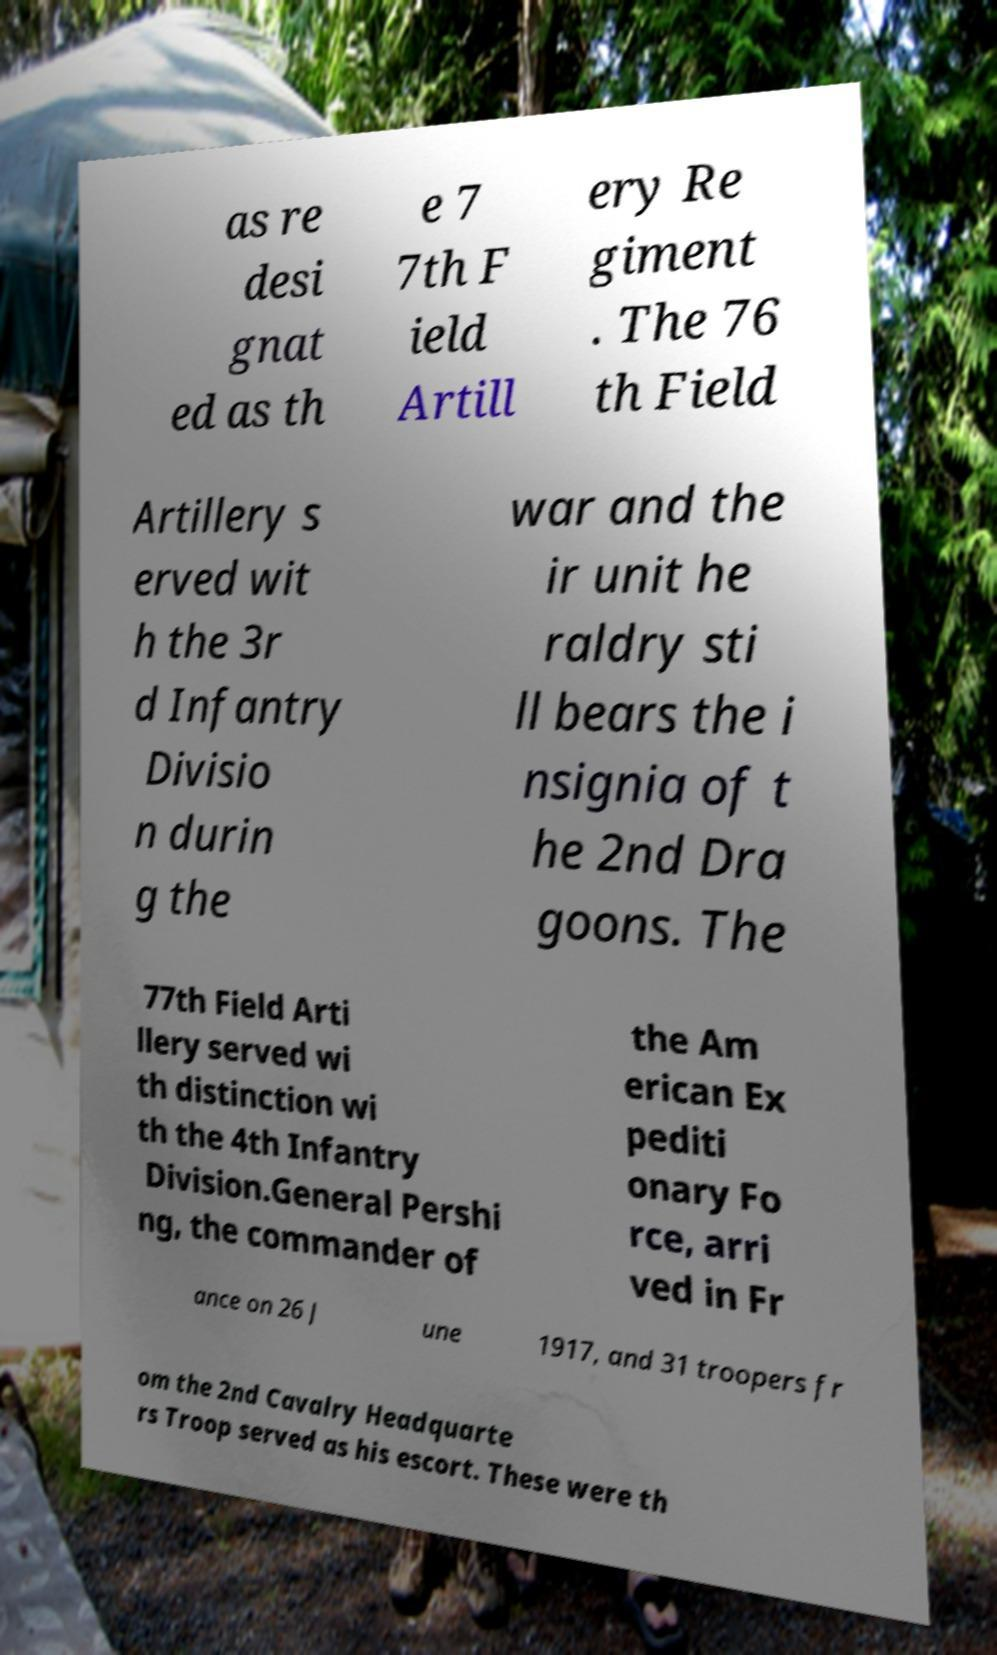Can you accurately transcribe the text from the provided image for me? as re desi gnat ed as th e 7 7th F ield Artill ery Re giment . The 76 th Field Artillery s erved wit h the 3r d Infantry Divisio n durin g the war and the ir unit he raldry sti ll bears the i nsignia of t he 2nd Dra goons. The 77th Field Arti llery served wi th distinction wi th the 4th Infantry Division.General Pershi ng, the commander of the Am erican Ex pediti onary Fo rce, arri ved in Fr ance on 26 J une 1917, and 31 troopers fr om the 2nd Cavalry Headquarte rs Troop served as his escort. These were th 